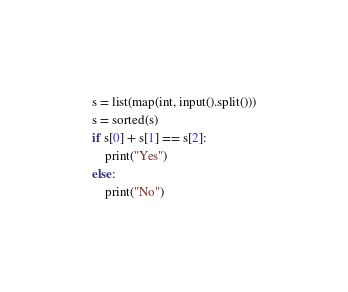<code> <loc_0><loc_0><loc_500><loc_500><_Python_>s = list(map(int, input().split()))
s = sorted(s)
if s[0] + s[1] == s[2]:
    print("Yes")
else:
    print("No")</code> 